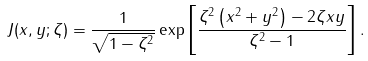<formula> <loc_0><loc_0><loc_500><loc_500>J ( x , y ; \zeta ) = \frac { 1 } { \sqrt { 1 - \zeta ^ { 2 } } } \exp \left [ \frac { \zeta ^ { 2 } \left ( x ^ { 2 } + y ^ { 2 } \right ) - 2 \zeta x y } { \zeta ^ { 2 } - 1 } \right ] .</formula> 